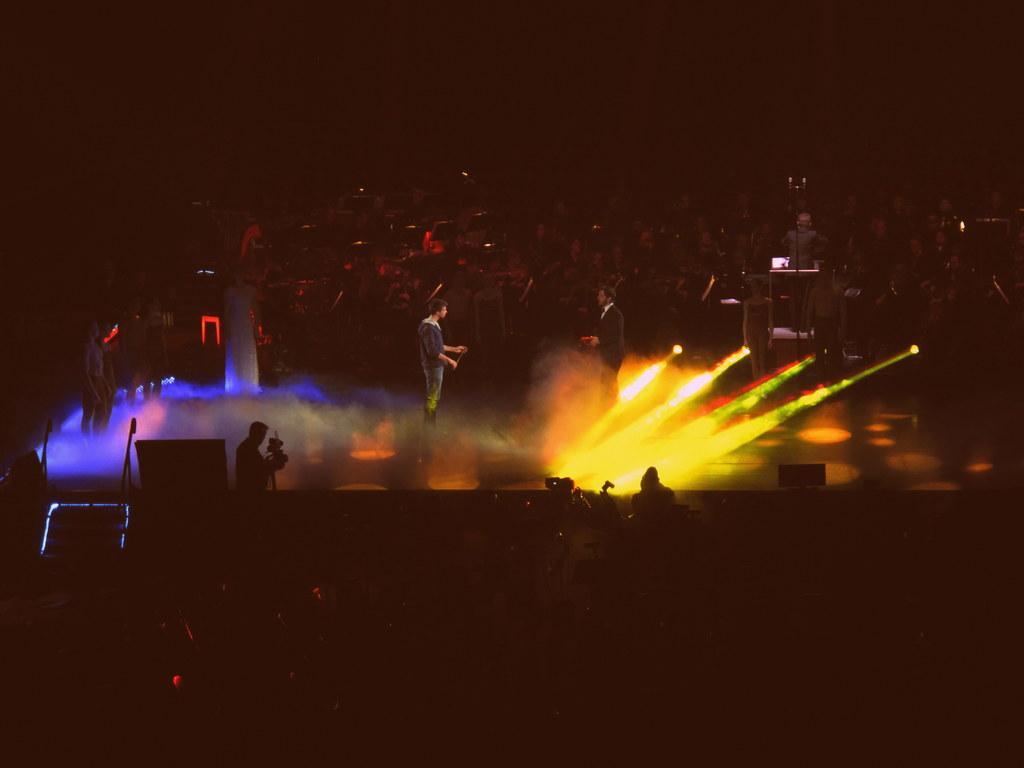In one or two sentences, can you explain what this image depicts? In the picture we can see a two men are standing on the stage in the dark and some DJ lights focus on them and near to them, we can see one person is holding the camera and standing and near to them we can see many people are sitting in the dark. 